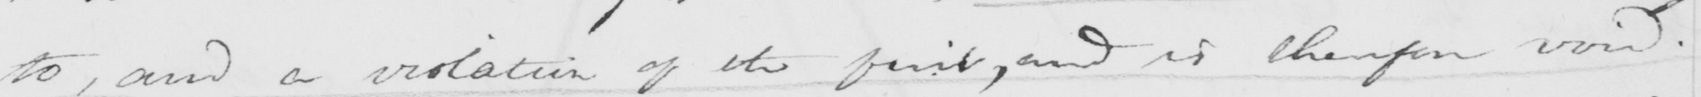Transcribe the text shown in this historical manuscript line. to , and a violation of the first , and is therefore void . 